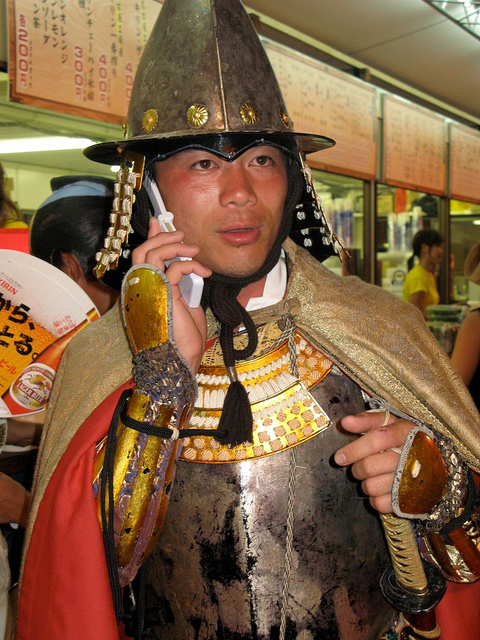Read all the text in this image. 2 3 5, IRIN 